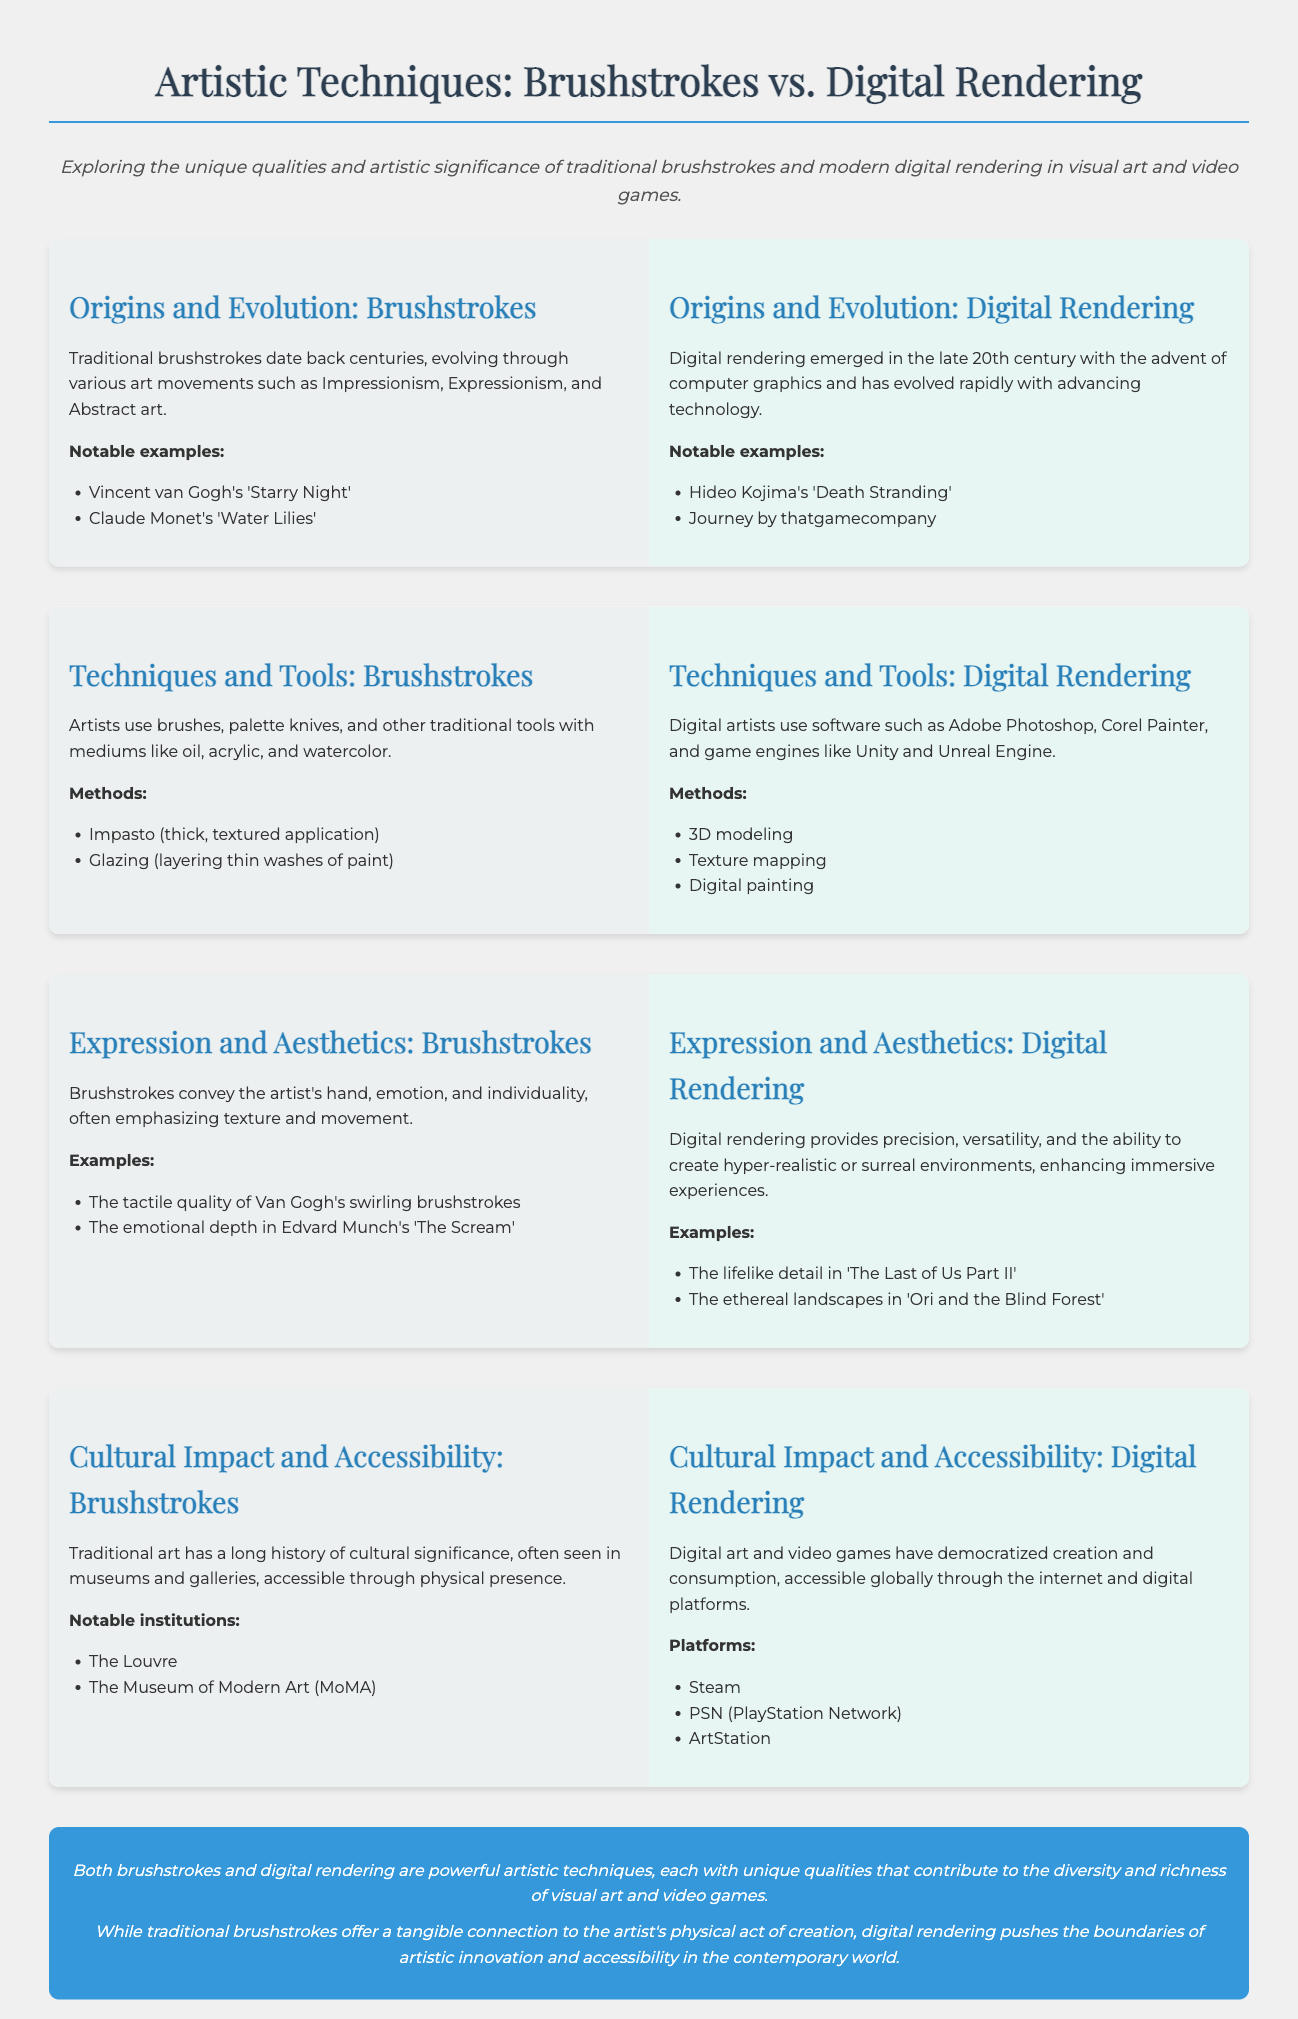what are two notable examples of brushstrokes? The document lists Vincent van Gogh's 'Starry Night' and Claude Monet's 'Water Lilies' as notable examples of brushstrokes.
Answer: 'Starry Night', 'Water Lilies' which art movements influenced the evolution of brushstrokes? The document mentions Impressionism, Expressionism, and Abstract art as movements that influenced brushstrokes.
Answer: Impressionism, Expressionism, Abstract art what software do digital artists commonly use? The document specifies software such as Adobe Photoshop, Corel Painter, and game engines like Unity and Unreal Engine for digital rendering.
Answer: Adobe Photoshop, Corel Painter, Unity, Unreal Engine how do brushstrokes convey emotion? Brushstrokes emphasize texture and movement, reflecting the artist's hand and individuality, conveying emotion.
Answer: Texture and movement what is one method used in digital rendering? The document lists 3D modeling as one of the methods used in digital rendering.
Answer: 3D modeling which type of art is more accessible globally? The document states that digital art and video games have democratized creation and consumption, making them more accessible.
Answer: Digital art and video games which institution is mentioned for traditional brushstrokes? The document refers to The Museum of Modern Art (MoMA) as one of the institutions for traditional brushstrokes.
Answer: The Museum of Modern Art (MoMA) what aspect of digital rendering enhances immersive experiences? The ability to create hyper-realistic or surreal environments in digital rendering enhances immersive experiences.
Answer: Hyper-realistic or surreal environments which two games are given as notable examples of digital rendering? The document mentions Hideo Kojima's 'Death Stranding' and Journey by thatgamecompany as notable examples of digital rendering.
Answer: 'Death Stranding', Journey 